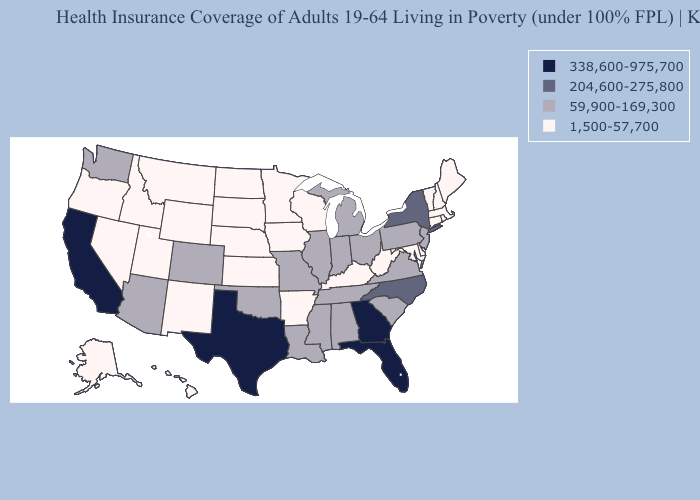Among the states that border Illinois , does Wisconsin have the highest value?
Keep it brief. No. What is the highest value in states that border Kansas?
Concise answer only. 59,900-169,300. Name the states that have a value in the range 59,900-169,300?
Give a very brief answer. Alabama, Arizona, Colorado, Illinois, Indiana, Louisiana, Michigan, Mississippi, Missouri, New Jersey, Ohio, Oklahoma, Pennsylvania, South Carolina, Tennessee, Virginia, Washington. What is the lowest value in the USA?
Write a very short answer. 1,500-57,700. What is the value of Illinois?
Quick response, please. 59,900-169,300. What is the highest value in the USA?
Give a very brief answer. 338,600-975,700. What is the highest value in the MidWest ?
Keep it brief. 59,900-169,300. What is the value of Maine?
Answer briefly. 1,500-57,700. What is the lowest value in the USA?
Answer briefly. 1,500-57,700. Name the states that have a value in the range 338,600-975,700?
Short answer required. California, Florida, Georgia, Texas. What is the value of Alaska?
Answer briefly. 1,500-57,700. Is the legend a continuous bar?
Keep it brief. No. What is the value of Wisconsin?
Answer briefly. 1,500-57,700. What is the lowest value in the USA?
Give a very brief answer. 1,500-57,700. 